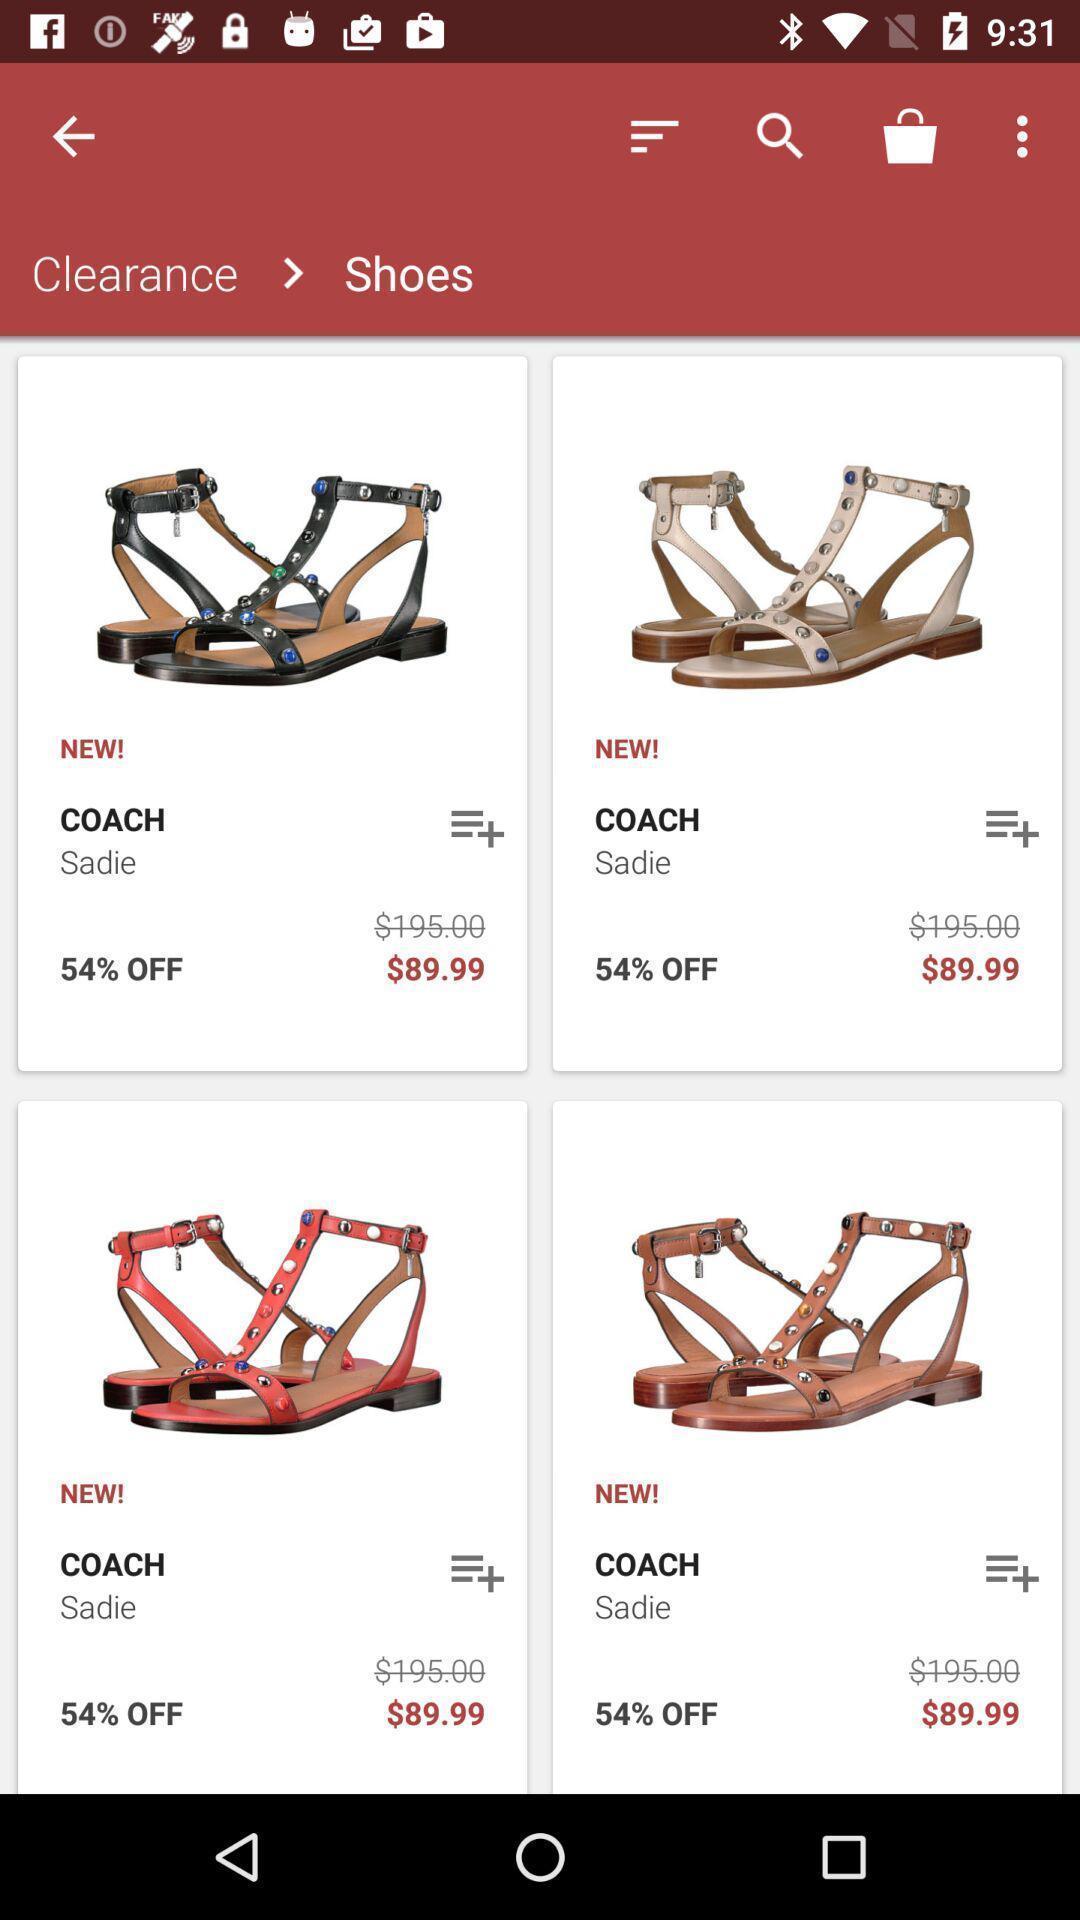Describe the content in this image. Screen displaying multiple products with sale price. 